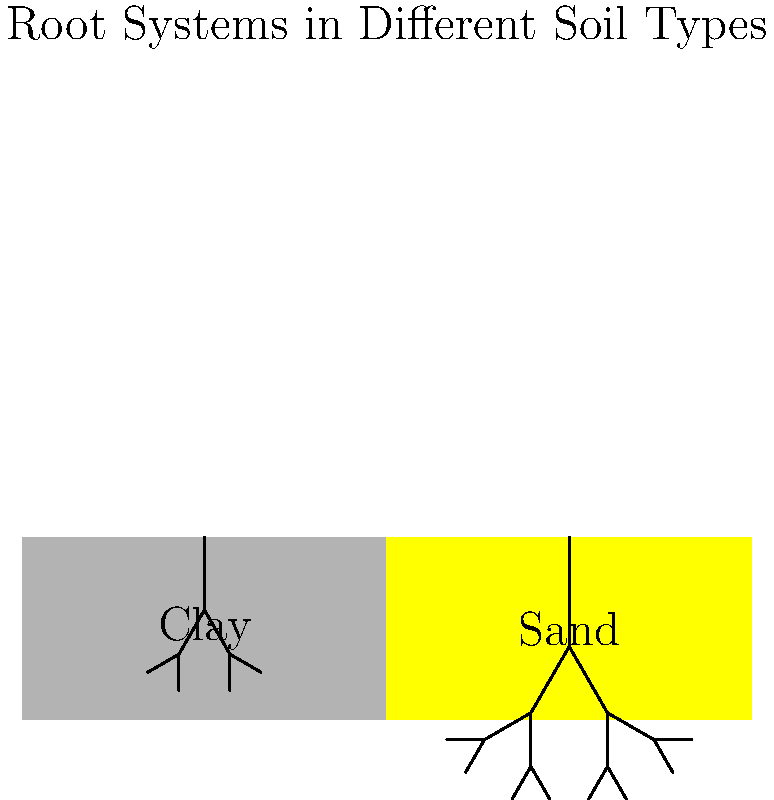Compare the root systems of plants growing in clay and sandy soils as shown in the diagram. Which soil type allows for deeper root penetration, and how does this affect the plant's ability to access water and nutrients? To answer this question, let's analyze the root systems in both soil types:

1. Clay soil:
   - The roots are shorter and less spread out.
   - They form a more compact system near the surface.
   - This is due to the dense, compact nature of clay soil.

2. Sandy soil:
   - The roots are longer and more extensively branched.
   - They penetrate deeper into the soil.
   - This is because sandy soil is looser and allows for easier root growth.

3. Root penetration:
   - Sandy soil allows for deeper root penetration.
   - This is evident from the longer and more extensive root system in the sandy soil illustration.

4. Effects on water and nutrient access:
   - Deeper roots in sandy soil allow plants to access water from lower soil layers, which is crucial as sandy soils drain quickly.
   - The extensive root system increases the surface area for nutrient absorption.
   - In clay soil, while water retention is better, the compact root system may limit the plant's ability to access nutrients from a larger soil volume.

5. Adaptation:
   - Plants in sandy soil develop deeper roots to reach water tables and maximize nutrient uptake from a larger soil volume.
   - Plants in clay soil develop shallower, more compact root systems to cope with poor aeration and potential waterlogging.

Therefore, sandy soil allows for deeper root penetration, which enhances the plant's ability to access water from deeper soil layers and nutrients from a larger soil volume, crucial for plant survival in well-draining sandy soils.
Answer: Sandy soil; deeper roots access more water and nutrients. 